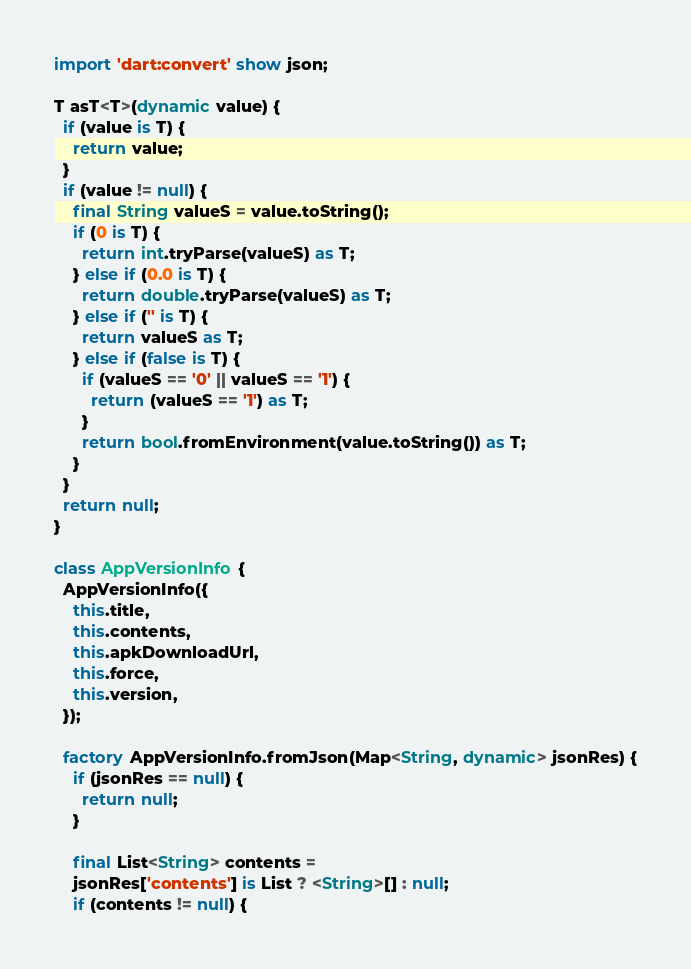Convert code to text. <code><loc_0><loc_0><loc_500><loc_500><_Dart_>import 'dart:convert' show json;

T asT<T>(dynamic value) {
  if (value is T) {
    return value;
  }
  if (value != null) {
    final String valueS = value.toString();
    if (0 is T) {
      return int.tryParse(valueS) as T;
    } else if (0.0 is T) {
      return double.tryParse(valueS) as T;
    } else if ('' is T) {
      return valueS as T;
    } else if (false is T) {
      if (valueS == '0' || valueS == '1') {
        return (valueS == '1') as T;
      }
      return bool.fromEnvironment(value.toString()) as T;
    }
  }
  return null;
}

class AppVersionInfo {
  AppVersionInfo({
    this.title,
    this.contents,
    this.apkDownloadUrl,
    this.force,
    this.version,
  });

  factory AppVersionInfo.fromJson(Map<String, dynamic> jsonRes) {
    if (jsonRes == null) {
      return null;
    }

    final List<String> contents =
    jsonRes['contents'] is List ? <String>[] : null;
    if (contents != null) {</code> 